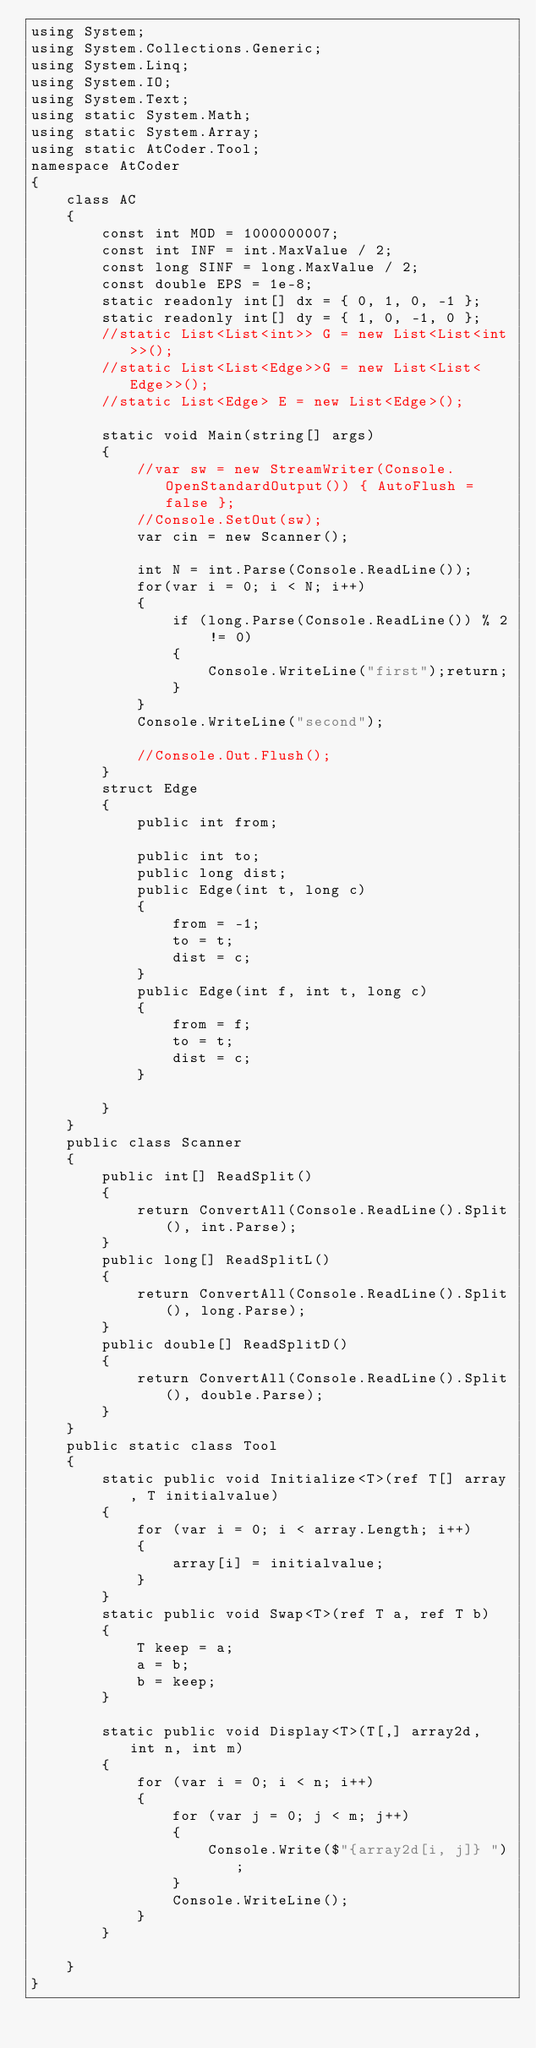Convert code to text. <code><loc_0><loc_0><loc_500><loc_500><_C#_>using System;
using System.Collections.Generic;
using System.Linq;
using System.IO;
using System.Text;
using static System.Math;
using static System.Array;
using static AtCoder.Tool;
namespace AtCoder
{
    class AC
    {
        const int MOD = 1000000007;
        const int INF = int.MaxValue / 2;
        const long SINF = long.MaxValue / 2;
        const double EPS = 1e-8;
        static readonly int[] dx = { 0, 1, 0, -1 };
        static readonly int[] dy = { 1, 0, -1, 0 };
        //static List<List<int>> G = new List<List<int>>();
        //static List<List<Edge>>G = new List<List<Edge>>();
        //static List<Edge> E = new List<Edge>();
        
        static void Main(string[] args)
        {
            //var sw = new StreamWriter(Console.OpenStandardOutput()) { AutoFlush = false };
            //Console.SetOut(sw);
            var cin = new Scanner();

            int N = int.Parse(Console.ReadLine());
            for(var i = 0; i < N; i++)
            {
                if (long.Parse(Console.ReadLine()) % 2 != 0)
                {
                    Console.WriteLine("first");return;
                }
            }
            Console.WriteLine("second");
            
            //Console.Out.Flush();
        }
        struct Edge
        {
            public int from;

            public int to;
            public long dist;
            public Edge(int t, long c)
            {
                from = -1;
                to = t;
                dist = c;
            }
            public Edge(int f, int t, long c)
            {
                from = f;
                to = t;
                dist = c;
            }

        }
    }
    public class Scanner
    {
        public int[] ReadSplit()
        {
            return ConvertAll(Console.ReadLine().Split(), int.Parse);
        }
        public long[] ReadSplitL()
        {
            return ConvertAll(Console.ReadLine().Split(), long.Parse);
        }
        public double[] ReadSplitD()
        {
            return ConvertAll(Console.ReadLine().Split(), double.Parse);
        }
    }
    public static class Tool
    {
        static public void Initialize<T>(ref T[] array, T initialvalue)
        {
            for (var i = 0; i < array.Length; i++)
            {
                array[i] = initialvalue;
            }
        }
        static public void Swap<T>(ref T a, ref T b)
        {
            T keep = a;
            a = b;
            b = keep;
        }

        static public void Display<T>(T[,] array2d, int n, int m)
        {
            for (var i = 0; i < n; i++)
            {
                for (var j = 0; j < m; j++)
                {
                    Console.Write($"{array2d[i, j]} ");
                }
                Console.WriteLine();
            }
        }

    }
}
</code> 